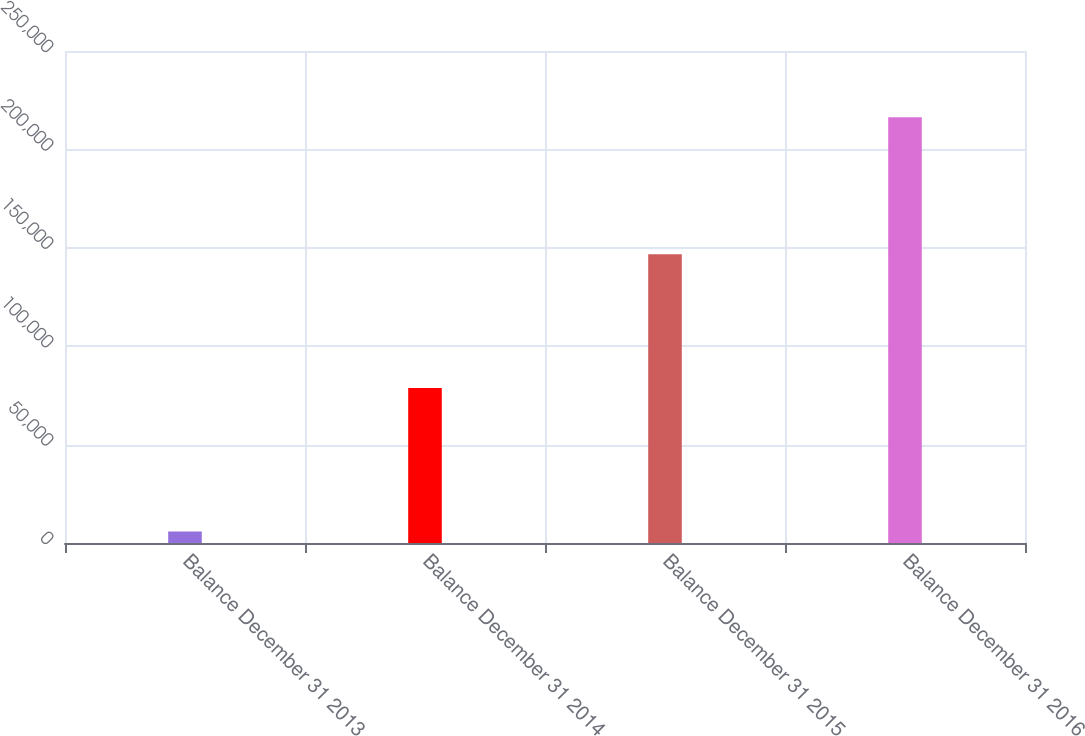Convert chart. <chart><loc_0><loc_0><loc_500><loc_500><bar_chart><fcel>Balance December 31 2013<fcel>Balance December 31 2014<fcel>Balance December 31 2015<fcel>Balance December 31 2016<nl><fcel>5879<fcel>78705<fcel>146726<fcel>216280<nl></chart> 